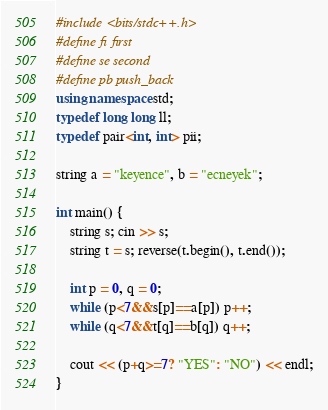<code> <loc_0><loc_0><loc_500><loc_500><_C++_>#include <bits/stdc++.h>
#define fi first
#define se second
#define pb push_back
using namespace std;
typedef long long ll;
typedef pair<int, int> pii;

string a = "keyence", b = "ecneyek";

int main() {
    string s; cin >> s;
    string t = s; reverse(t.begin(), t.end());

    int p = 0, q = 0;
    while (p<7&&s[p]==a[p]) p++;
    while (q<7&&t[q]==b[q]) q++;

    cout << (p+q>=7? "YES": "NO") << endl;
}
</code> 